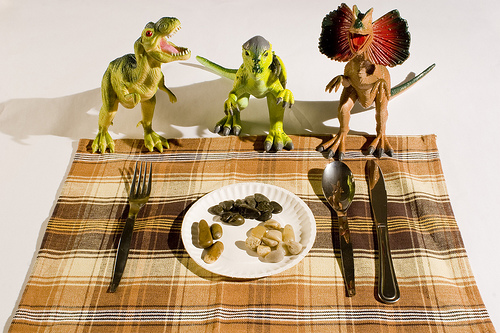<image>
Is the spoon behind the knife? No. The spoon is not behind the knife. From this viewpoint, the spoon appears to be positioned elsewhere in the scene. 